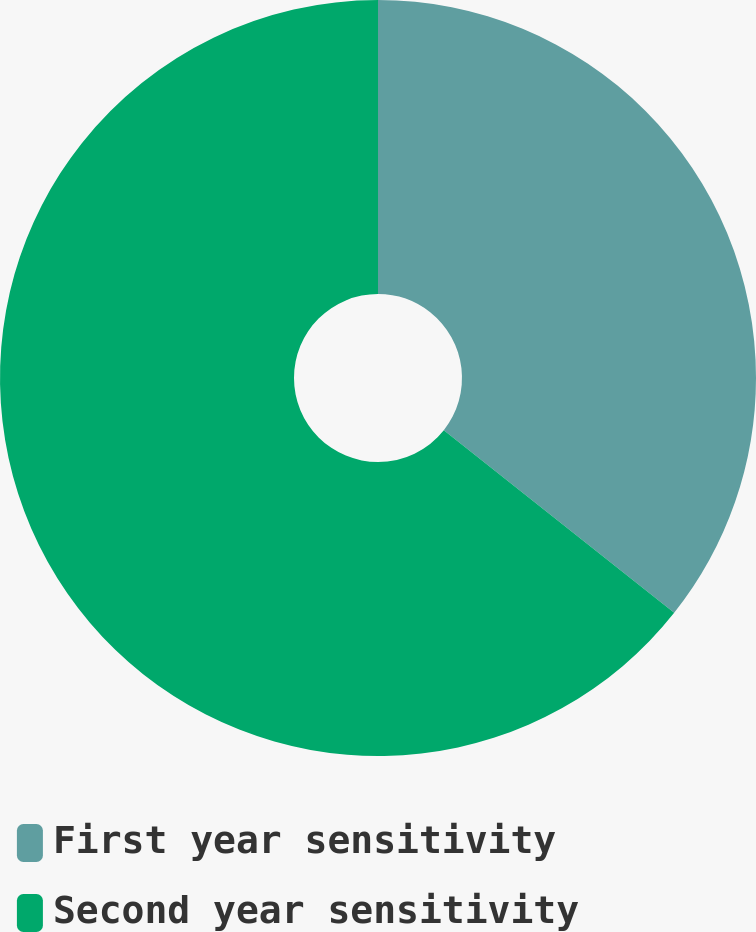<chart> <loc_0><loc_0><loc_500><loc_500><pie_chart><fcel>First year sensitivity<fcel>Second year sensitivity<nl><fcel>35.67%<fcel>64.33%<nl></chart> 